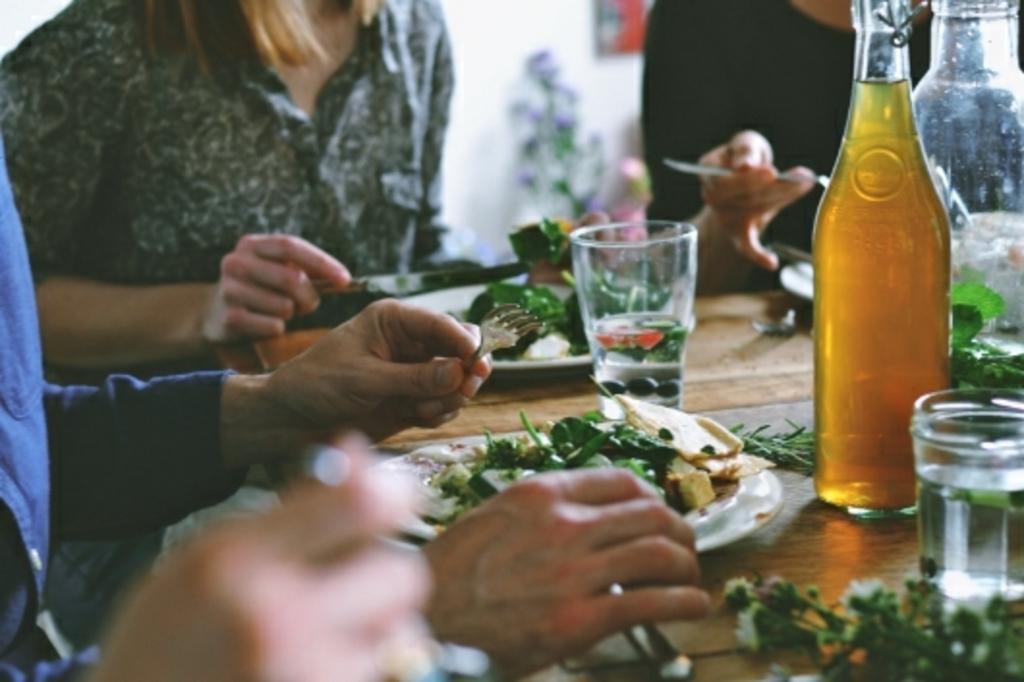In one or two sentences, can you explain what this image depicts? In this picture, we see three people sitting on chair around the table. On the table, we see glass containing water, cool drink bottle, plate containing food, fork, spoon are placed and behind them, we see a white wall. 